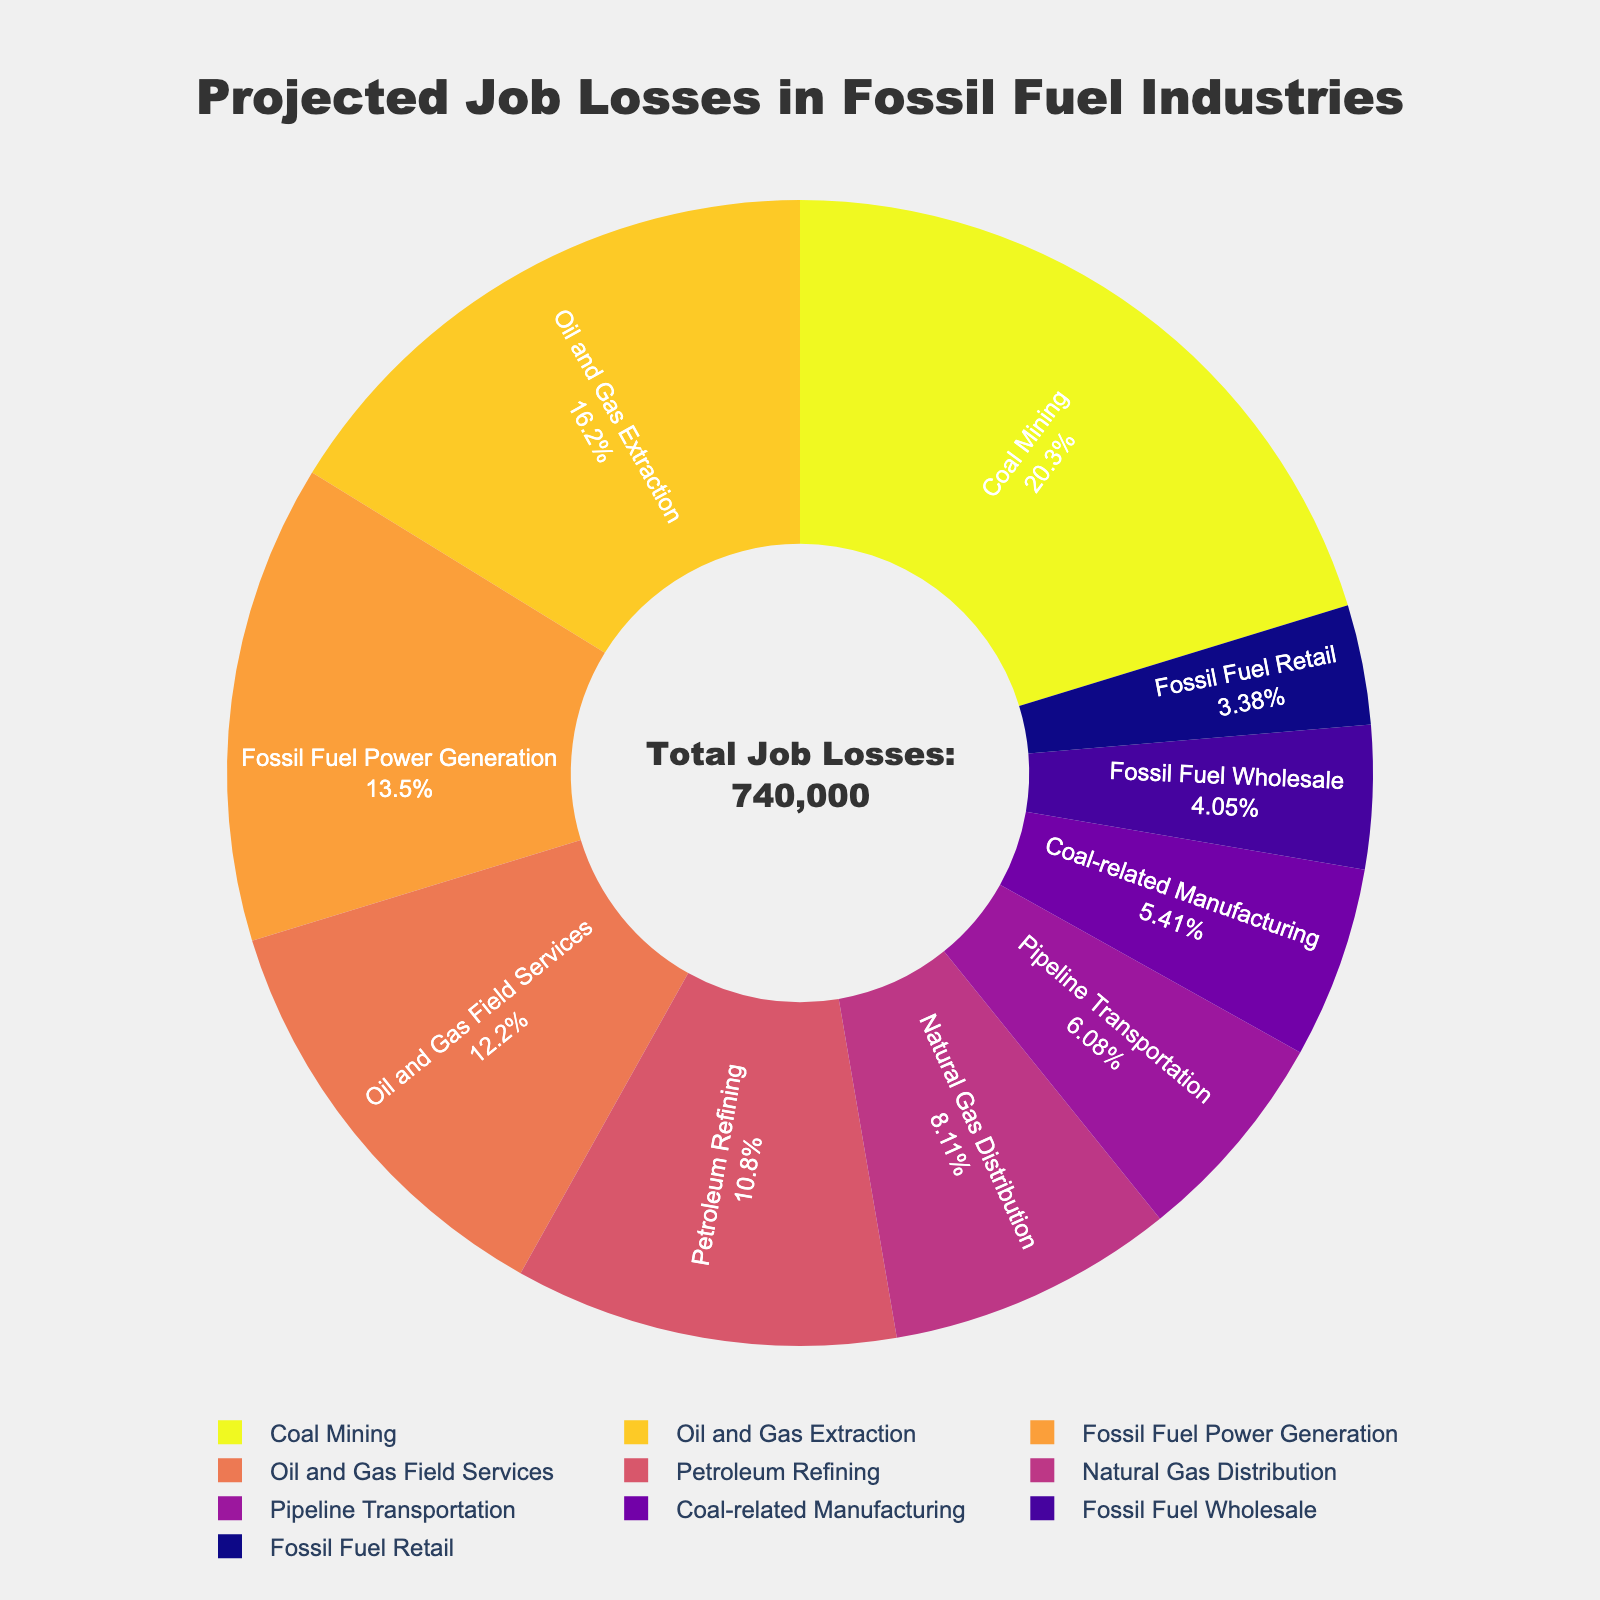Which industry has the highest projected job losses? Look for the segment that occupies the largest area in the pie chart. Here, it is labeled as "Coal Mining."
Answer: Coal Mining Which industries have projected job losses greater than 100,000? Observe which segments represent values over 100,000. These are "Coal Mining" and "Oil and Gas Extraction."
Answer: Coal Mining, Oil and Gas Extraction What is the combined projected job loss for Oil and Gas Extraction and Petroleum Refining? Add the job losses for Oil and Gas Extraction (120,000) and Petroleum Refining (80,000). 120,000 + 80,000 = 200,000.
Answer: 200,000 Which industries show the smallest projected job losses individually? Identify the smallest segments. These are "Fossil Fuel Retail" and "Fossil Fuel Wholesale."
Answer: Fossil Fuel Wholesale, Fossil Fuel Retail What is the total projected job loss for sectors related to natural gas (Natural Gas Distribution and Pipeline Transportation)? Sum the job losses for Natural Gas Distribution (60,000) and Pipeline Transportation (45,000). 60,000 + 45,000 = 105,000.
Answer: 105,000 Are the projected job losses for Oil and Gas Field Services greater than those for Fossil Fuel Power Generation? Compare the job losses for Oil and Gas Field Services (90,000) and Fossil Fuel Power Generation (100,000). Since 90,000 < 100,000, the answer is no.
Answer: No Which industry has the highest job losses after Coal Mining? Look for the largest segment after "Coal Mining" which is "Oil and Gas Extraction."
Answer: Oil and Gas Extraction What percentage of the total projected job losses is represented by Coal Mining? Calculate the percentage by dividing Coal Mining job losses (150,000) by the total job losses. Then multiply by 100. Total job losses can be found in the annotation (661,000). (150,000 / 661,000) * 100 ≈ 22.69%.
Answer: 22.69% What is the difference in projected job losses between Petroleum Refining and Fossil Fuel Power Generation? Subtract the job losses of Petroleum Refining (80,000) from Fossil Fuel Power Generation (100,000). 100,000 - 80,000 = 20,000.
Answer: 20,000 How many industries have projected job losses between 40,000 and 90,000? Count the segments that fall within this range. They are "Oil and Gas Field Services" (90,000), "Natural Gas Distribution" (60,000), "Pipeline Transportation" (45,000), and "Coal-related Manufacturing" (40,000). Four in total.
Answer: 4 